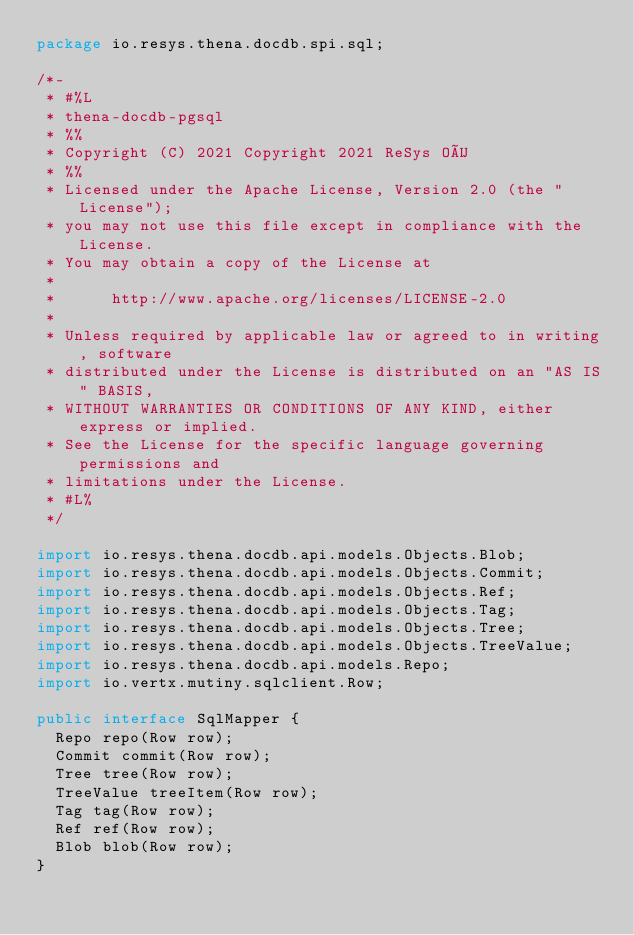Convert code to text. <code><loc_0><loc_0><loc_500><loc_500><_Java_>package io.resys.thena.docdb.spi.sql;

/*-
 * #%L
 * thena-docdb-pgsql
 * %%
 * Copyright (C) 2021 Copyright 2021 ReSys OÜ
 * %%
 * Licensed under the Apache License, Version 2.0 (the "License");
 * you may not use this file except in compliance with the License.
 * You may obtain a copy of the License at
 * 
 *      http://www.apache.org/licenses/LICENSE-2.0
 * 
 * Unless required by applicable law or agreed to in writing, software
 * distributed under the License is distributed on an "AS IS" BASIS,
 * WITHOUT WARRANTIES OR CONDITIONS OF ANY KIND, either express or implied.
 * See the License for the specific language governing permissions and
 * limitations under the License.
 * #L%
 */

import io.resys.thena.docdb.api.models.Objects.Blob;
import io.resys.thena.docdb.api.models.Objects.Commit;
import io.resys.thena.docdb.api.models.Objects.Ref;
import io.resys.thena.docdb.api.models.Objects.Tag;
import io.resys.thena.docdb.api.models.Objects.Tree;
import io.resys.thena.docdb.api.models.Objects.TreeValue;
import io.resys.thena.docdb.api.models.Repo;
import io.vertx.mutiny.sqlclient.Row;

public interface SqlMapper {
  Repo repo(Row row);
  Commit commit(Row row);
  Tree tree(Row row);
  TreeValue treeItem(Row row);
  Tag tag(Row row);
  Ref ref(Row row);
  Blob blob(Row row);
}
</code> 